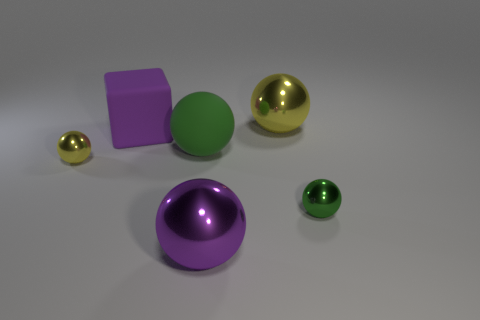Subtract all gray balls. Subtract all red cylinders. How many balls are left? 5 Add 2 tiny green rubber cubes. How many objects exist? 8 Subtract all cubes. How many objects are left? 5 Add 5 large purple objects. How many large purple objects are left? 7 Add 4 yellow spheres. How many yellow spheres exist? 6 Subtract 0 green blocks. How many objects are left? 6 Subtract all large yellow objects. Subtract all big yellow spheres. How many objects are left? 4 